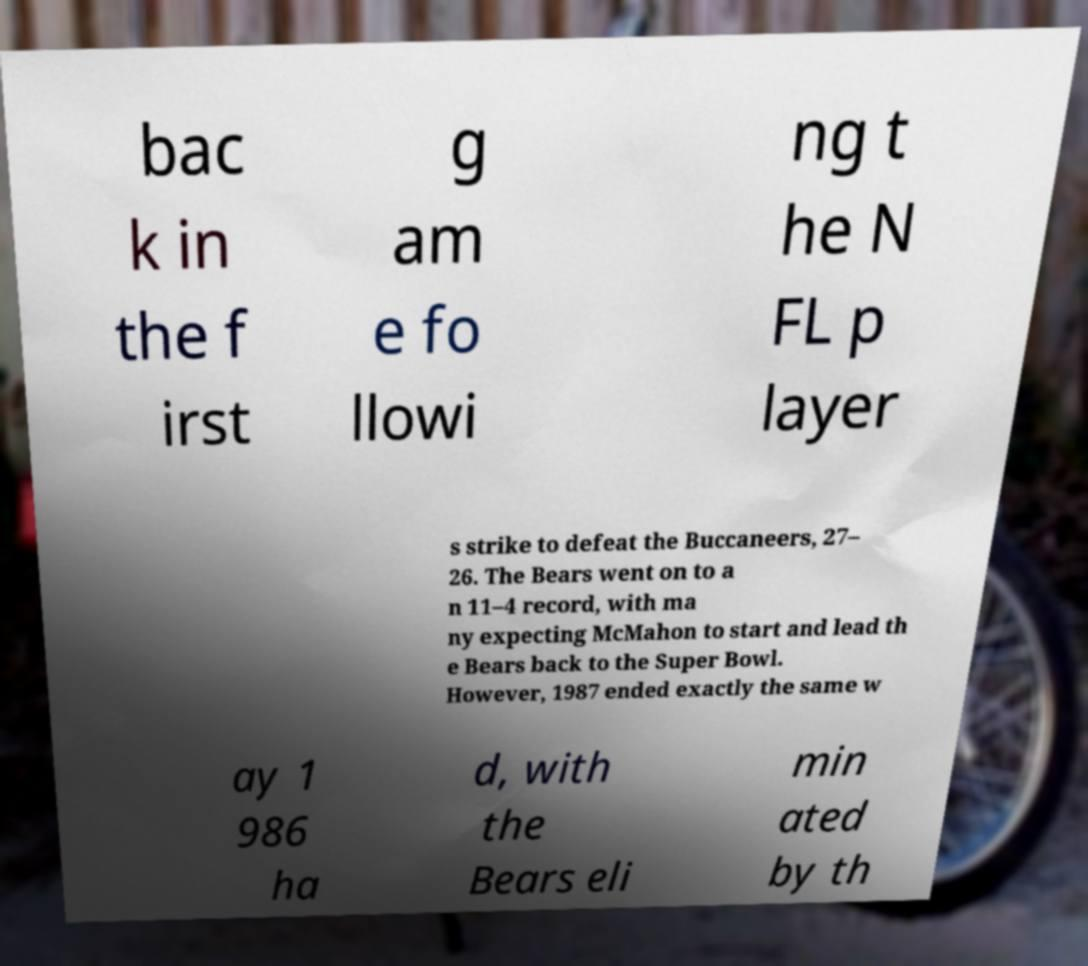Please identify and transcribe the text found in this image. bac k in the f irst g am e fo llowi ng t he N FL p layer s strike to defeat the Buccaneers, 27– 26. The Bears went on to a n 11–4 record, with ma ny expecting McMahon to start and lead th e Bears back to the Super Bowl. However, 1987 ended exactly the same w ay 1 986 ha d, with the Bears eli min ated by th 